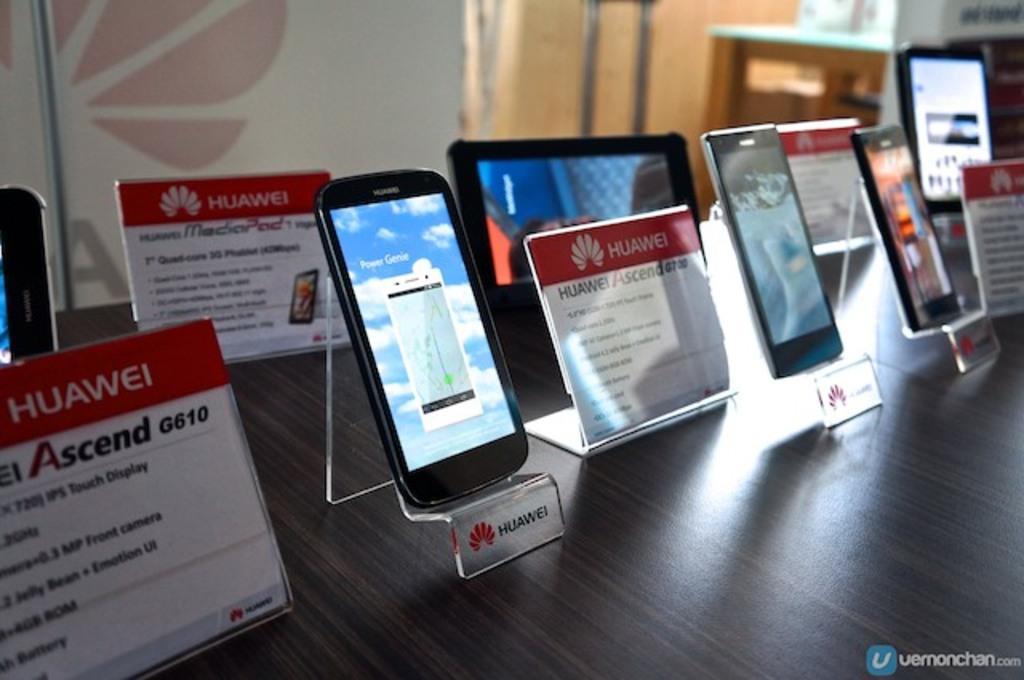<image>
Write a terse but informative summary of the picture. A variety of huawei branded cell phones arranged for display on a table. 